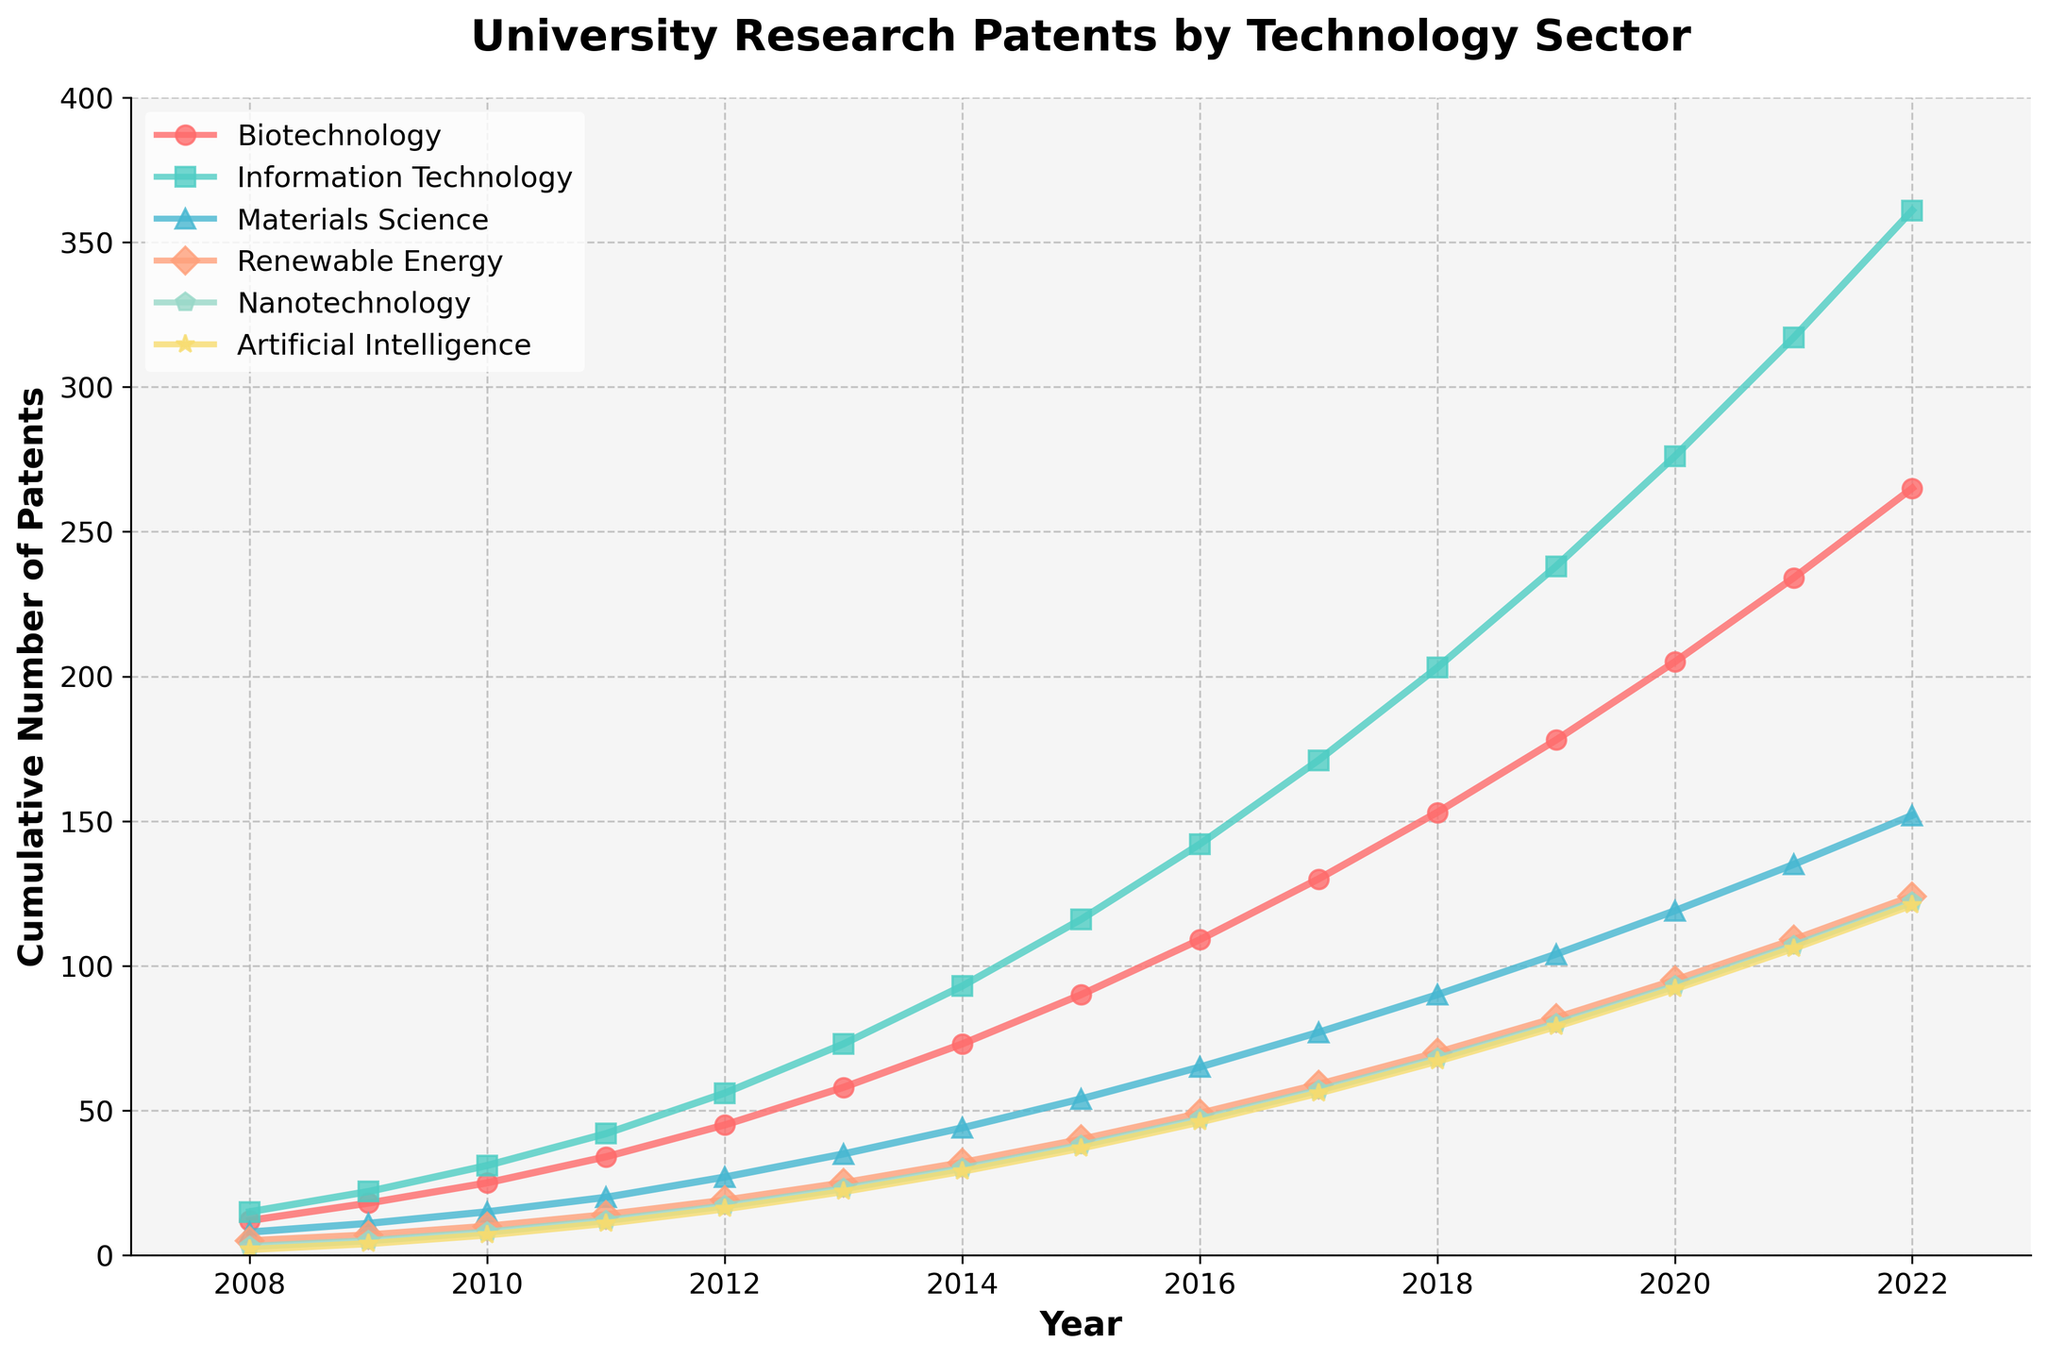What technology sector started with the highest number of patents in 2008? Looking at the initial values in 2008, Information Technology has the highest starting value, which is 15 patents.
Answer: Information Technology In which year did Biotechnology surpass 100 cumulative patents? The Biotechnology line crosses the 100-mark between 2015 and 2016. In 2016, Biotechnology reached 109 cumulative patents.
Answer: 2016 How many cumulative patents were filed in Nanotechnology by the year 2020? Refer to the Nanotechnology line and find the corresponding value for 2020, which is 93.
Answer: 93 Which sectors surpassed 200 cumulative patents by 2020? Information Technology, Biotechnology, and Artificial Intelligence each had more than 200 patents. This can be confirmed by looking at their respective lines at the 2020 mark, with values of 276, 205, and 202, respectively.
Answer: Information Technology, Biotechnology, Artificial Intelligence What is the difference in the cumulative number of patents between Materials Science and Renewable Energy in 2022? For 2022, Materials Science has 152 patents, and Renewable Energy has 124 patents. The difference is 152 - 124 = 28.
Answer: 28 How many cumulative patents were filed in Artificial Intelligence over the last three years (2020-2022)? Add the values for Artificial Intelligence for 2020, 2021, and 2022: 92 (2020) + 106 (2021) + 121 (2022) = 319.
Answer: 319 Which sector had the steepest growth from 2013 to 2014? By visual inspection, the Information Technology line shows the steepest rise between 2013 and 2014. The number of patents increased from 73 to 93, a difference of 20.
Answer: Information Technology Among all sectors, which one has the slowest cumulative growth through the 15 years? Nanotechnology consistently has the lowest cumulative number of patents compared to other sectors, indicating the slowest growth.
Answer: Nanotechnology What is the average number of cumulative patents in Biotechnology every 5 years? Calculate the cumulative patents in Biotechnology for every 5-year interval: 2008 (12 patents), 2013 (58 patents), 2018 (153 patents), 2022 (265 patents). Taking the total and averaging them over the spans:
(12+58+153+265)/4 = 488/4 = 122
Answer: 122 